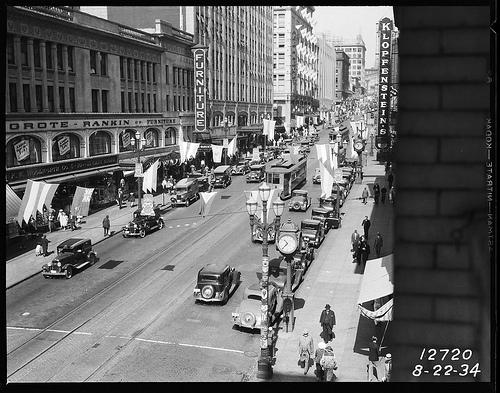What is in the street? cars 